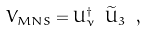Convert formula to latex. <formula><loc_0><loc_0><loc_500><loc_500>V _ { M N S } = U ^ { \dagger } _ { \nu } \ \widetilde { U } _ { 3 } \ ,</formula> 